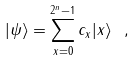Convert formula to latex. <formula><loc_0><loc_0><loc_500><loc_500>| \psi \rangle = \sum _ { x = 0 } ^ { 2 ^ { n } - 1 } c _ { x } | x \rangle \ ,</formula> 